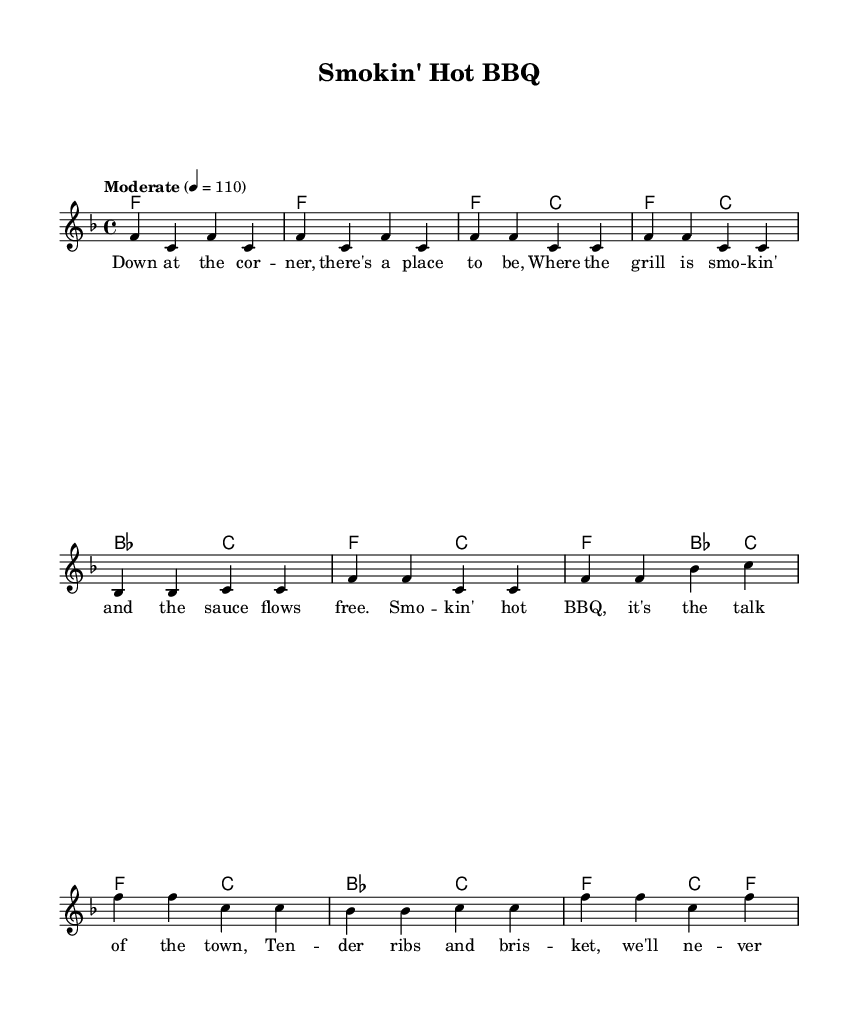What is the key signature of this music? The key signature indicates F major, which has one flat (B flat). This is determined by looking at the key signature at the beginning of the score.
Answer: F major What is the time signature of this music? The time signature is shown as 4/4, which indicates four beats per measure and a quarter note gets one beat. This can be found in the time signature notation at the beginning of the score.
Answer: 4/4 What is the tempo marking of the music? The tempo marking specifies the speed of the music. Here, it is indicated as "Moderate" with a metronome marking of 110 beats per minute. This is typically located at the beginning of the score near the time signature.
Answer: Moderate, 110 How many measures are there in the chorus section? To find the number of measures in the chorus, one must count the measures stated under the chorus lyrics. The chorus here consists of four measures.
Answer: 4 What is the first chord in the score? The first chord is indicated at the beginning of the score and is notated as F major. The chord symbols show this clearly in the chord section at the start of the music.
Answer: F What is the lyrical theme of the verse? The theme of the verse revolves around the ambiance of a BBQ joint, describing the location and the grilling process. This can be inferred from the words presented in the verse's lyrics.
Answer: BBQ atmosphere Which lyric is repeated in the chorus? The lyric "smokin' hot BBQ" is repeated in the chorus. This lyric can be seen appearing multiple times in the chorus section of the lyric layout, highlighting its importance.
Answer: Smokin' hot BBQ 